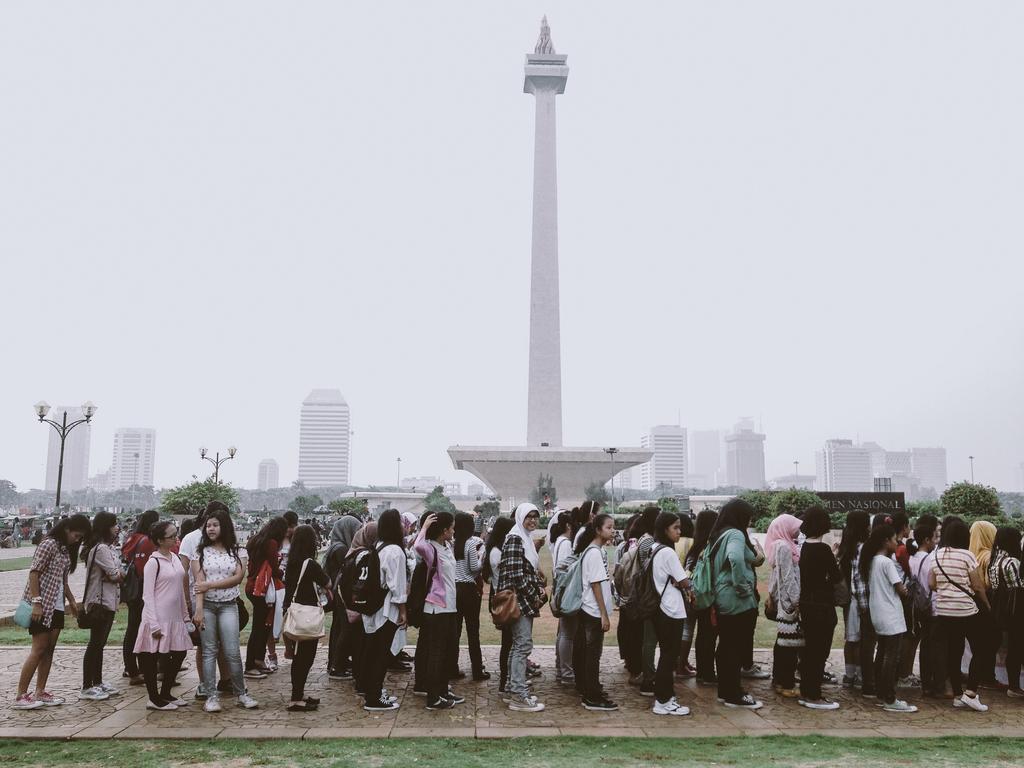How many people are in the group in the image? There is a group of people in the image, but the exact number cannot be determined from the provided facts. What are some people in the group wearing? Some people in the group are wearing bags. What can be seen in the background of the image? There are trees, poles, buildings, and a tower visible in the background of the image. Who is the owner of the board in the image? There is no board present in the image. 